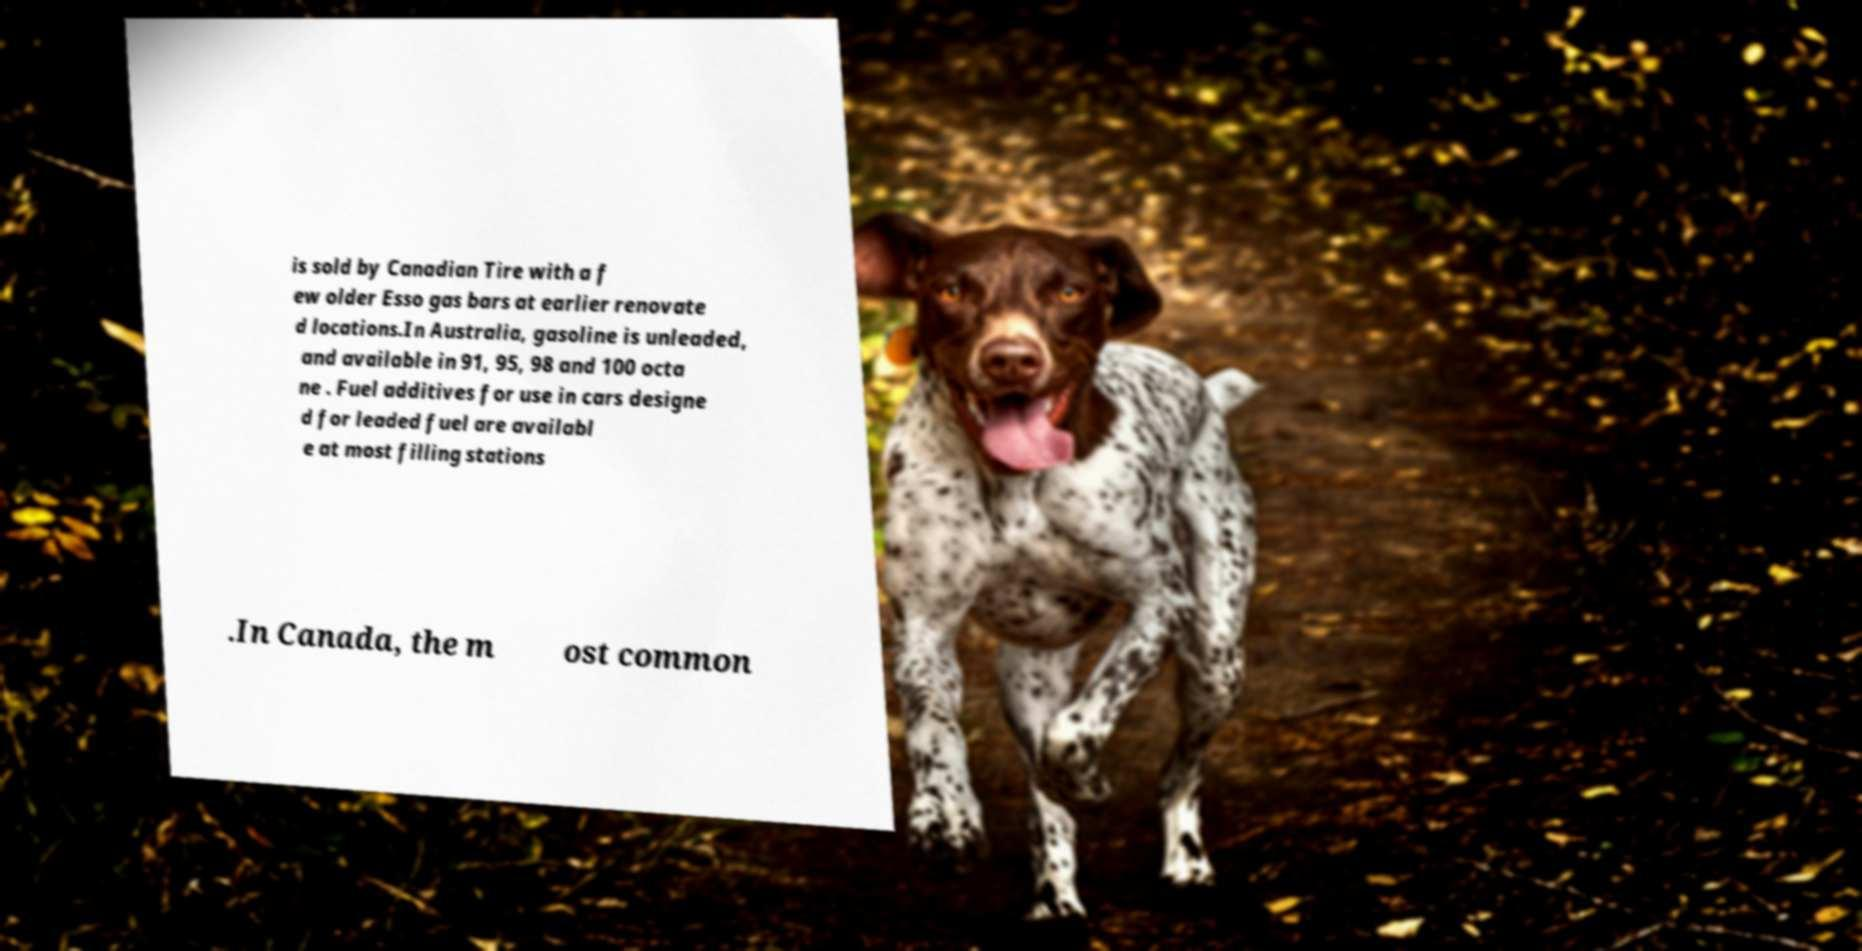Could you assist in decoding the text presented in this image and type it out clearly? is sold by Canadian Tire with a f ew older Esso gas bars at earlier renovate d locations.In Australia, gasoline is unleaded, and available in 91, 95, 98 and 100 octa ne . Fuel additives for use in cars designe d for leaded fuel are availabl e at most filling stations .In Canada, the m ost common 